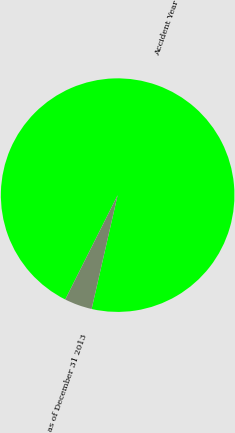Convert chart to OTSL. <chart><loc_0><loc_0><loc_500><loc_500><pie_chart><fcel>Accident Year<fcel>as of December 31 2013<nl><fcel>96.17%<fcel>3.83%<nl></chart> 